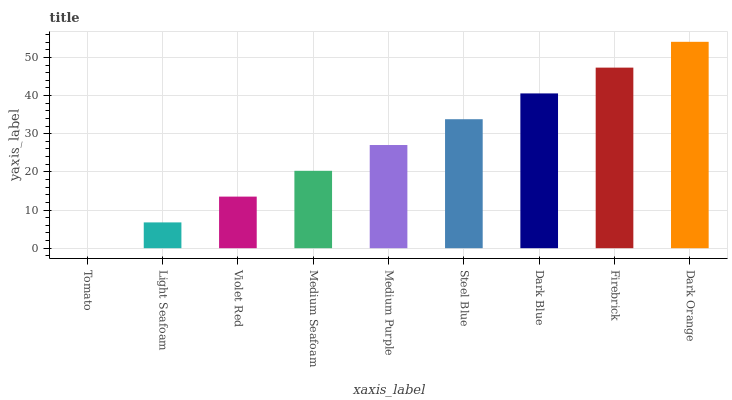Is Dark Orange the maximum?
Answer yes or no. Yes. Is Light Seafoam the minimum?
Answer yes or no. No. Is Light Seafoam the maximum?
Answer yes or no. No. Is Light Seafoam greater than Tomato?
Answer yes or no. Yes. Is Tomato less than Light Seafoam?
Answer yes or no. Yes. Is Tomato greater than Light Seafoam?
Answer yes or no. No. Is Light Seafoam less than Tomato?
Answer yes or no. No. Is Medium Purple the high median?
Answer yes or no. Yes. Is Medium Purple the low median?
Answer yes or no. Yes. Is Firebrick the high median?
Answer yes or no. No. Is Firebrick the low median?
Answer yes or no. No. 